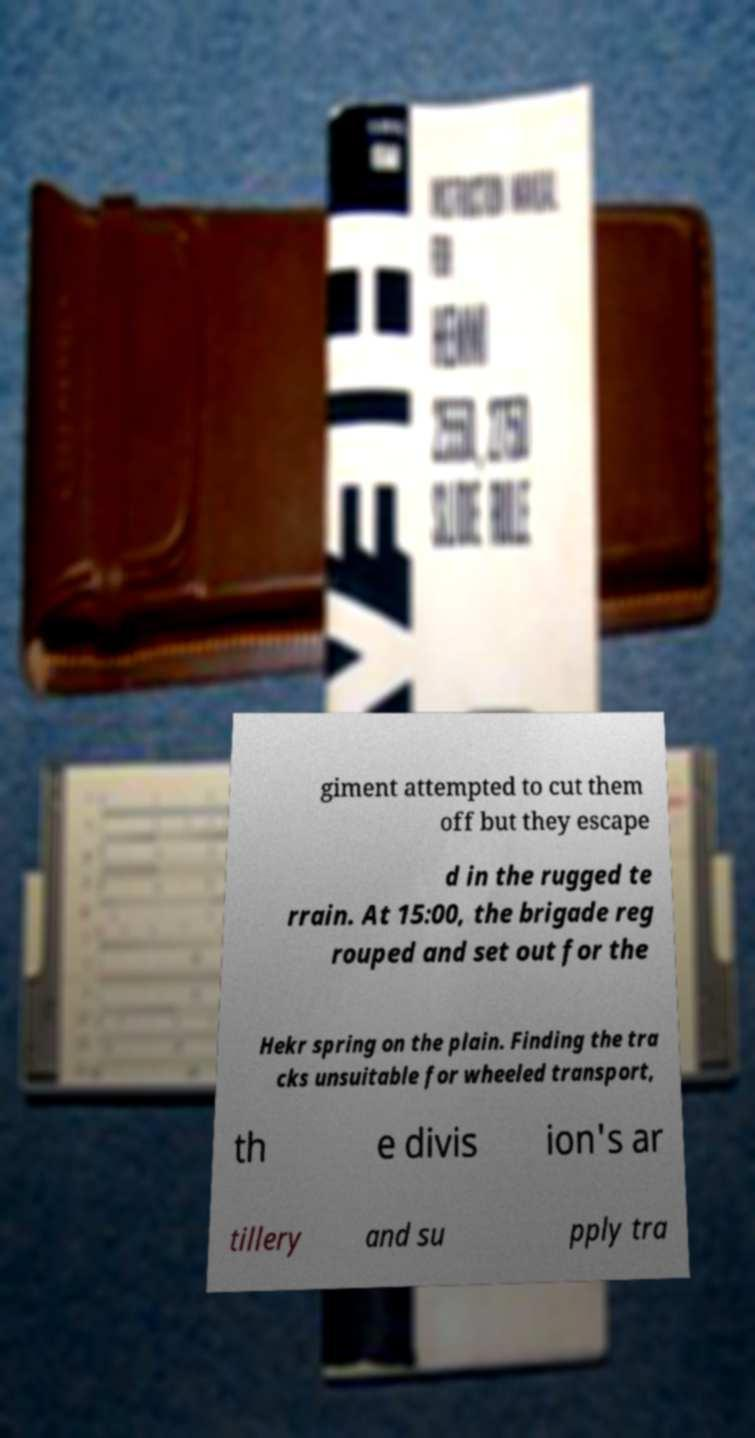There's text embedded in this image that I need extracted. Can you transcribe it verbatim? giment attempted to cut them off but they escape d in the rugged te rrain. At 15:00, the brigade reg rouped and set out for the Hekr spring on the plain. Finding the tra cks unsuitable for wheeled transport, th e divis ion's ar tillery and su pply tra 